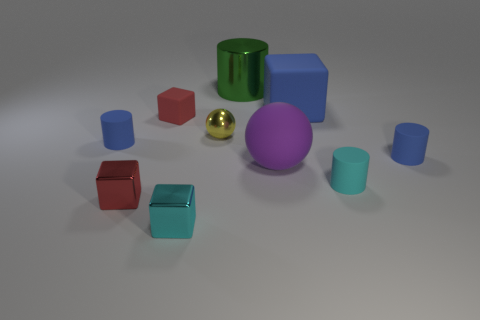What size is the thing that is the same color as the tiny matte block?
Make the answer very short. Small. Is the material of the big blue thing the same as the red block that is in front of the large ball?
Offer a very short reply. No. What is the size of the ball in front of the blue cylinder right of the big blue matte block?
Offer a very short reply. Large. Is there anything else of the same color as the matte sphere?
Your answer should be compact. No. Does the red object behind the purple ball have the same material as the blue cylinder that is to the right of the large purple object?
Provide a short and direct response. Yes. What material is the cube that is on the right side of the small rubber cube and in front of the small cyan matte cylinder?
Offer a very short reply. Metal. Does the cyan metal object have the same shape as the small shiny thing left of the cyan block?
Provide a succinct answer. Yes. What material is the small blue object to the left of the small block that is behind the blue matte object left of the tiny red shiny block?
Provide a short and direct response. Rubber. How many other things are there of the same size as the metal sphere?
Ensure brevity in your answer.  6. What number of objects are on the left side of the small blue rubber cylinder that is on the right side of the big matte thing behind the small yellow sphere?
Provide a succinct answer. 9. 